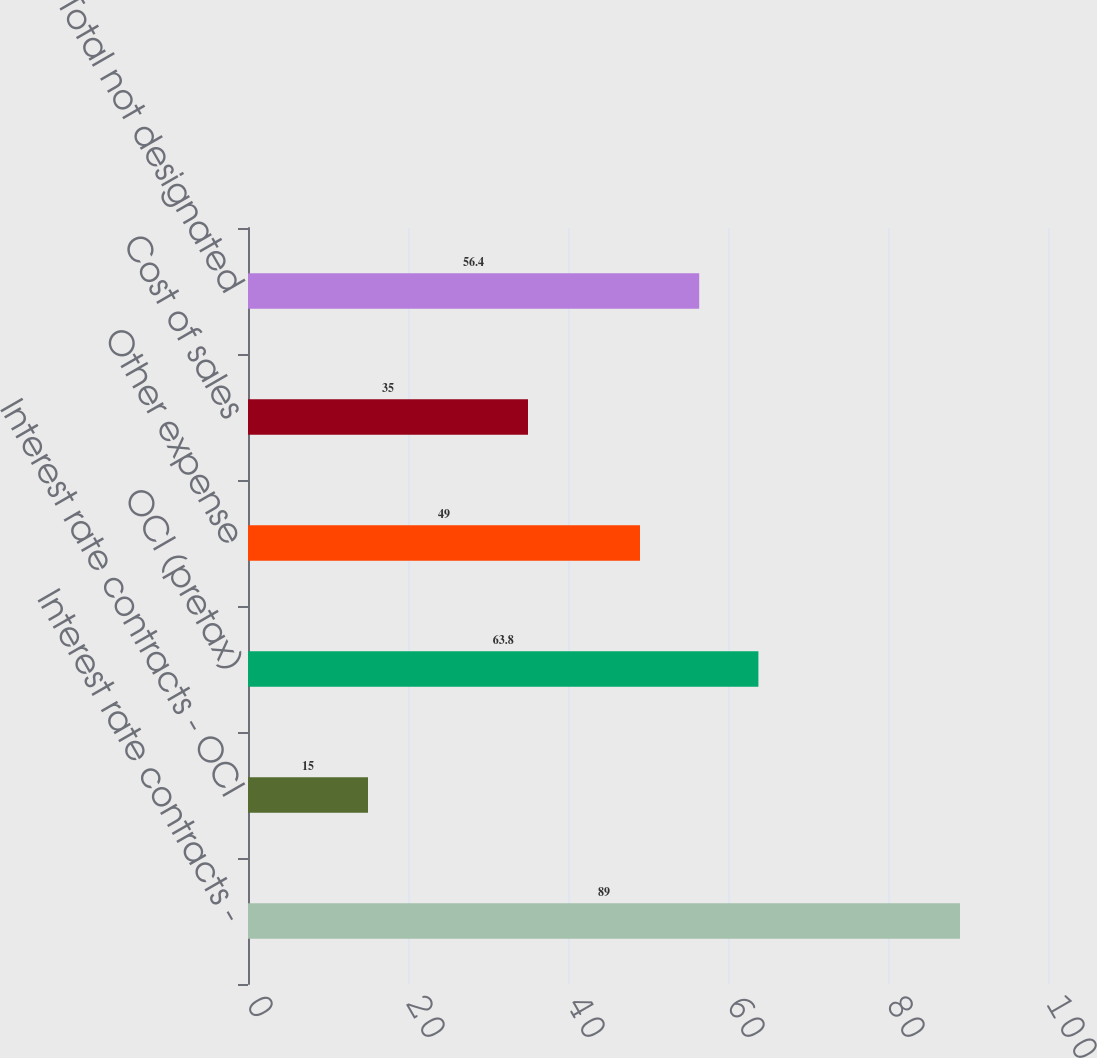<chart> <loc_0><loc_0><loc_500><loc_500><bar_chart><fcel>Interest rate contracts -<fcel>Interest rate contracts - OCI<fcel>OCI (pretax)<fcel>Other expense<fcel>Cost of sales<fcel>Total not designated<nl><fcel>89<fcel>15<fcel>63.8<fcel>49<fcel>35<fcel>56.4<nl></chart> 